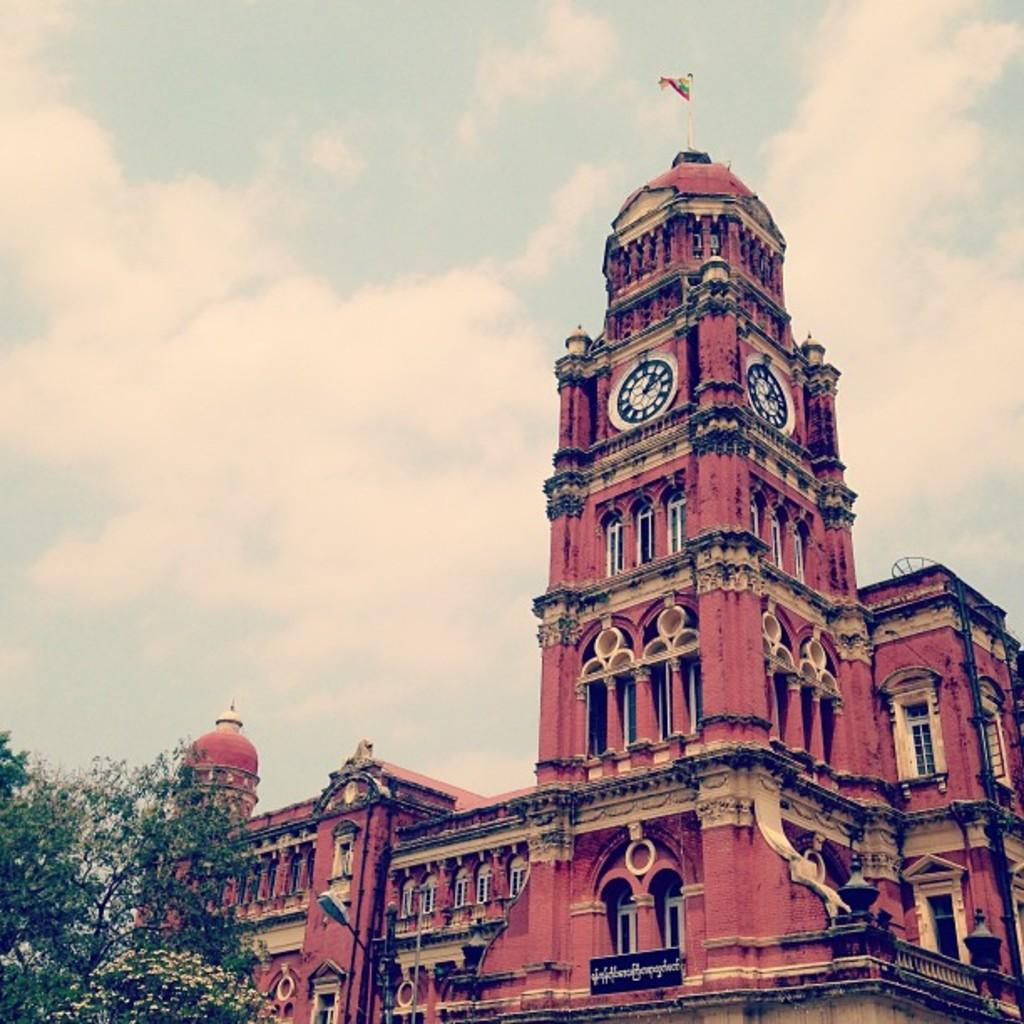What type of building is in the image? There is a clock tower building in the image. What is attached to the building? There is a flag on the building. What type of natural elements can be seen in the image? There are trees in the image. How would you describe the sky in the image? The sky is cloudy in the image. What brand of toothpaste is advertised on the clock tower building? There is no toothpaste or advertisement present on the clock tower building in the image. 